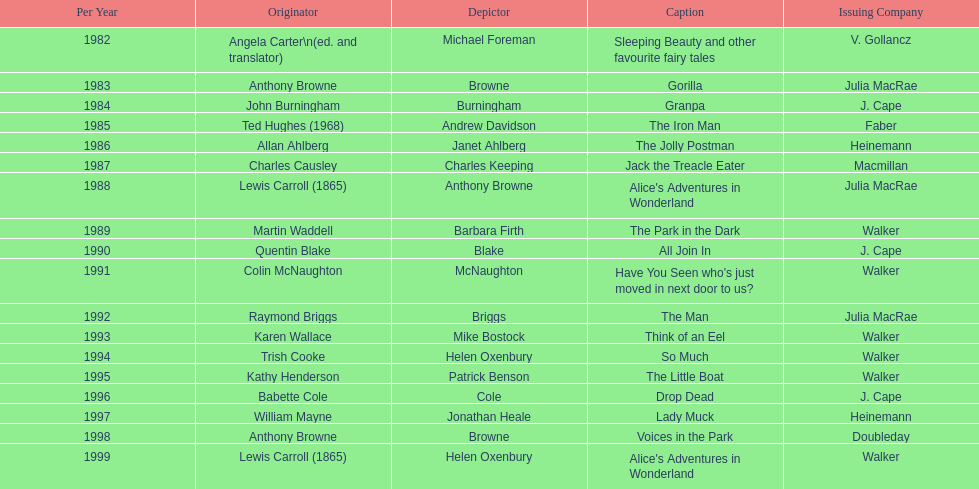How many number of titles are listed for the year 1991? 1. 